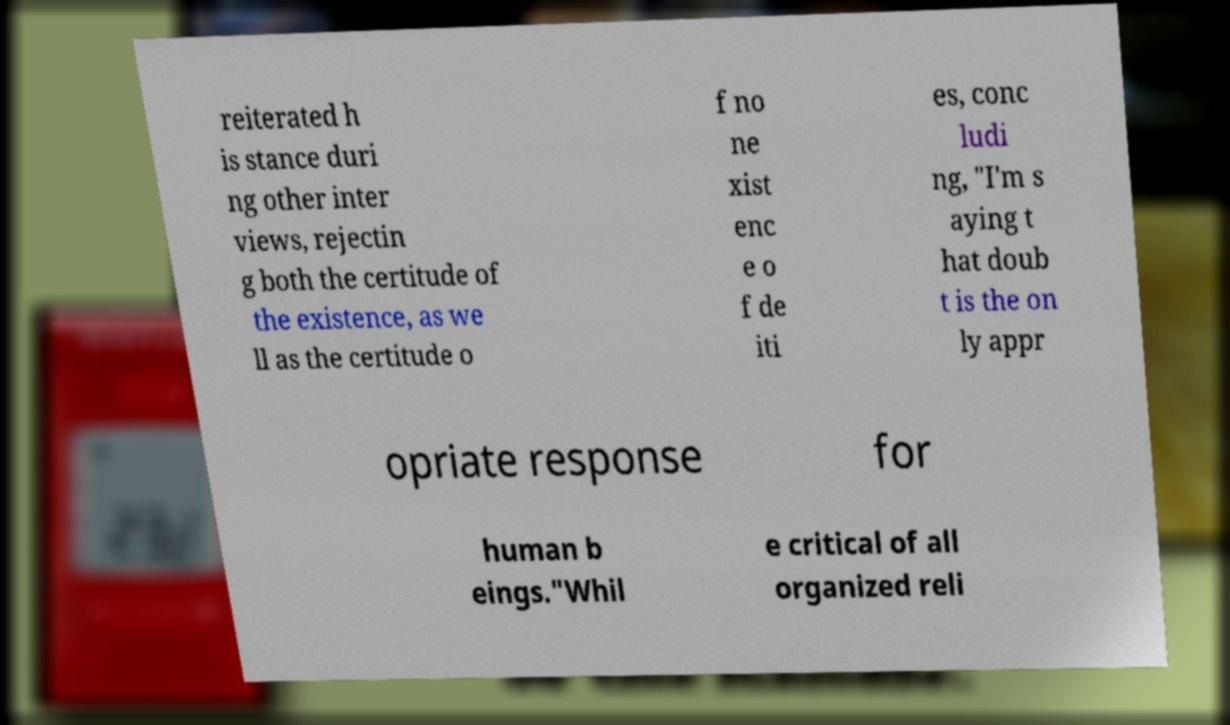What messages or text are displayed in this image? I need them in a readable, typed format. reiterated h is stance duri ng other inter views, rejectin g both the certitude of the existence, as we ll as the certitude o f no ne xist enc e o f de iti es, conc ludi ng, "I'm s aying t hat doub t is the on ly appr opriate response for human b eings."Whil e critical of all organized reli 